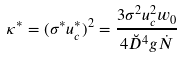Convert formula to latex. <formula><loc_0><loc_0><loc_500><loc_500>\kappa ^ { * } = ( \sigma ^ { * } u _ { c } ^ { * } ) ^ { 2 } = \frac { 3 \sigma ^ { 2 } u _ { c } ^ { 2 } w _ { 0 } } { 4 \breve { D } ^ { 4 } g \dot { N } }</formula> 